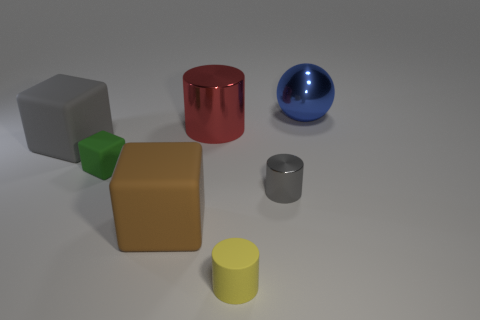Add 1 blue metal spheres. How many objects exist? 8 Subtract all metal cylinders. How many cylinders are left? 1 Subtract all blue balls. How many cyan cylinders are left? 0 Add 4 tiny cylinders. How many tiny cylinders exist? 6 Subtract all gray cylinders. How many cylinders are left? 2 Subtract 0 blue cylinders. How many objects are left? 7 Subtract all blocks. How many objects are left? 4 Subtract 1 spheres. How many spheres are left? 0 Subtract all red balls. Subtract all blue cylinders. How many balls are left? 1 Subtract all small blue spheres. Subtract all large spheres. How many objects are left? 6 